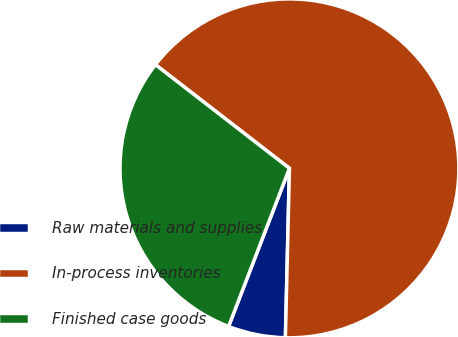<chart> <loc_0><loc_0><loc_500><loc_500><pie_chart><fcel>Raw materials and supplies<fcel>In-process inventories<fcel>Finished case goods<nl><fcel>5.47%<fcel>64.9%<fcel>29.63%<nl></chart> 